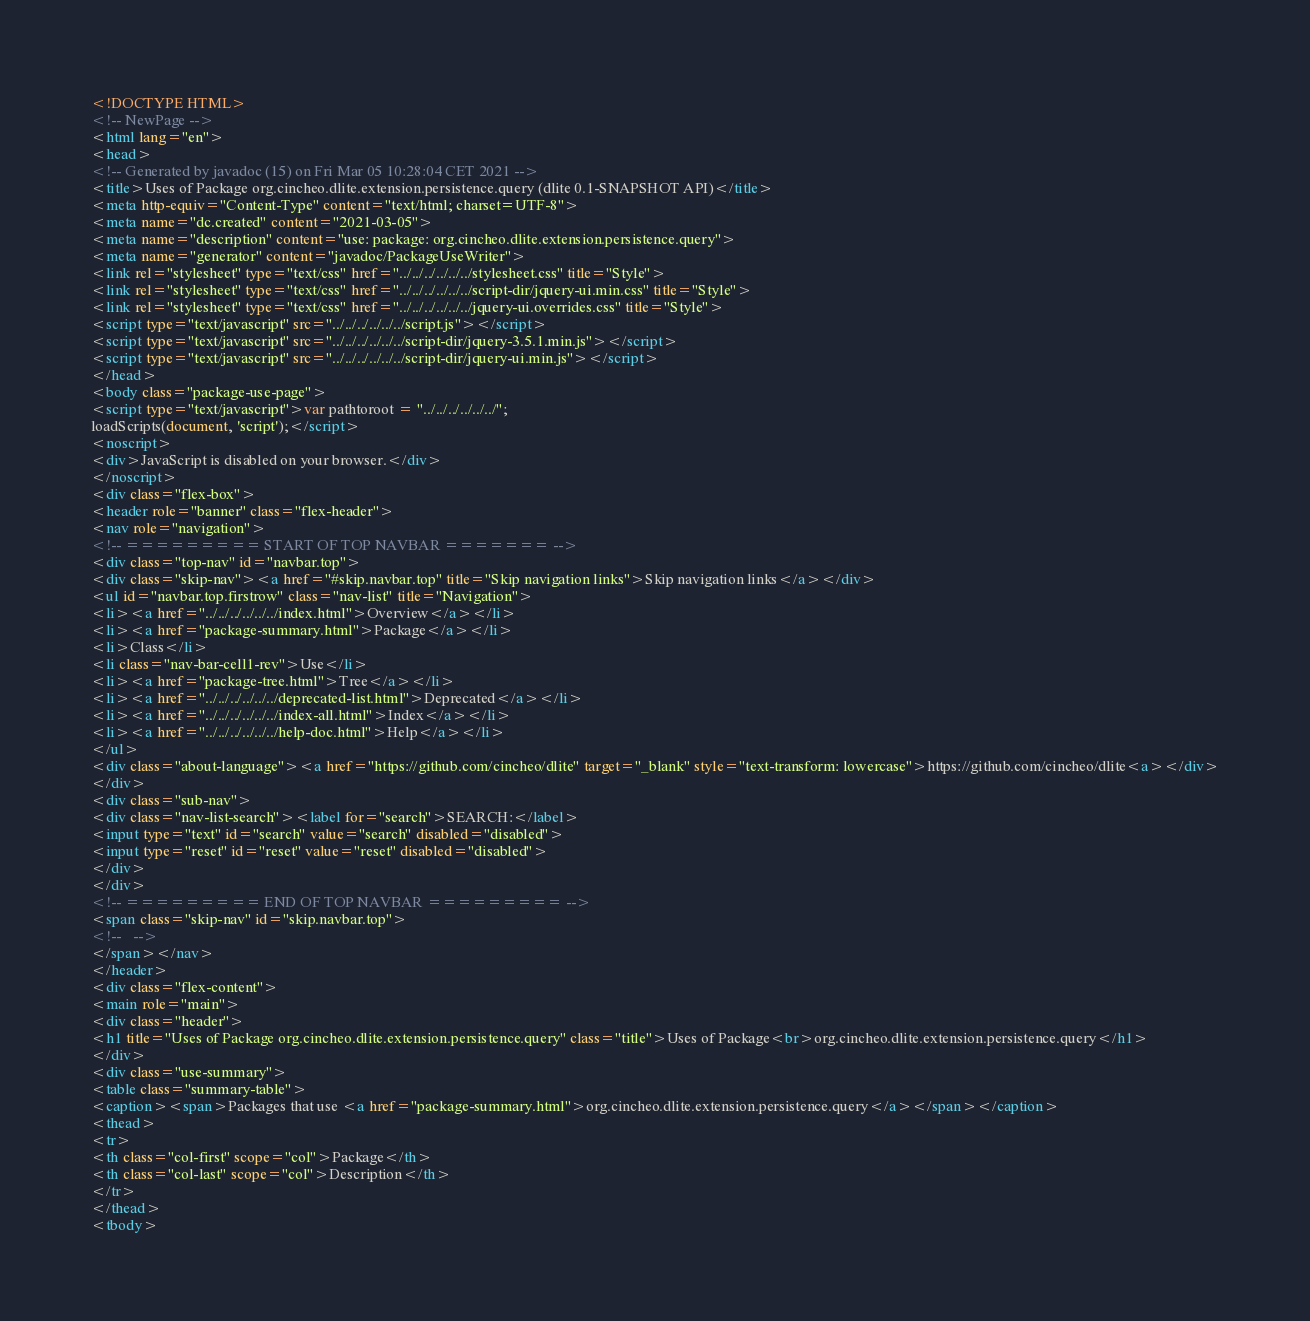<code> <loc_0><loc_0><loc_500><loc_500><_HTML_><!DOCTYPE HTML>
<!-- NewPage -->
<html lang="en">
<head>
<!-- Generated by javadoc (15) on Fri Mar 05 10:28:04 CET 2021 -->
<title>Uses of Package org.cincheo.dlite.extension.persistence.query (dlite 0.1-SNAPSHOT API)</title>
<meta http-equiv="Content-Type" content="text/html; charset=UTF-8">
<meta name="dc.created" content="2021-03-05">
<meta name="description" content="use: package: org.cincheo.dlite.extension.persistence.query">
<meta name="generator" content="javadoc/PackageUseWriter">
<link rel="stylesheet" type="text/css" href="../../../../../../stylesheet.css" title="Style">
<link rel="stylesheet" type="text/css" href="../../../../../../script-dir/jquery-ui.min.css" title="Style">
<link rel="stylesheet" type="text/css" href="../../../../../../jquery-ui.overrides.css" title="Style">
<script type="text/javascript" src="../../../../../../script.js"></script>
<script type="text/javascript" src="../../../../../../script-dir/jquery-3.5.1.min.js"></script>
<script type="text/javascript" src="../../../../../../script-dir/jquery-ui.min.js"></script>
</head>
<body class="package-use-page">
<script type="text/javascript">var pathtoroot = "../../../../../../";
loadScripts(document, 'script');</script>
<noscript>
<div>JavaScript is disabled on your browser.</div>
</noscript>
<div class="flex-box">
<header role="banner" class="flex-header">
<nav role="navigation">
<!-- ========= START OF TOP NAVBAR ======= -->
<div class="top-nav" id="navbar.top">
<div class="skip-nav"><a href="#skip.navbar.top" title="Skip navigation links">Skip navigation links</a></div>
<ul id="navbar.top.firstrow" class="nav-list" title="Navigation">
<li><a href="../../../../../../index.html">Overview</a></li>
<li><a href="package-summary.html">Package</a></li>
<li>Class</li>
<li class="nav-bar-cell1-rev">Use</li>
<li><a href="package-tree.html">Tree</a></li>
<li><a href="../../../../../../deprecated-list.html">Deprecated</a></li>
<li><a href="../../../../../../index-all.html">Index</a></li>
<li><a href="../../../../../../help-doc.html">Help</a></li>
</ul>
<div class="about-language"><a href="https://github.com/cincheo/dlite" target="_blank" style="text-transform: lowercase">https://github.com/cincheo/dlite<a></div>
</div>
<div class="sub-nav">
<div class="nav-list-search"><label for="search">SEARCH:</label>
<input type="text" id="search" value="search" disabled="disabled">
<input type="reset" id="reset" value="reset" disabled="disabled">
</div>
</div>
<!-- ========= END OF TOP NAVBAR ========= -->
<span class="skip-nav" id="skip.navbar.top">
<!--   -->
</span></nav>
</header>
<div class="flex-content">
<main role="main">
<div class="header">
<h1 title="Uses of Package org.cincheo.dlite.extension.persistence.query" class="title">Uses of Package<br>org.cincheo.dlite.extension.persistence.query</h1>
</div>
<div class="use-summary">
<table class="summary-table">
<caption><span>Packages that use <a href="package-summary.html">org.cincheo.dlite.extension.persistence.query</a></span></caption>
<thead>
<tr>
<th class="col-first" scope="col">Package</th>
<th class="col-last" scope="col">Description</th>
</tr>
</thead>
<tbody></code> 